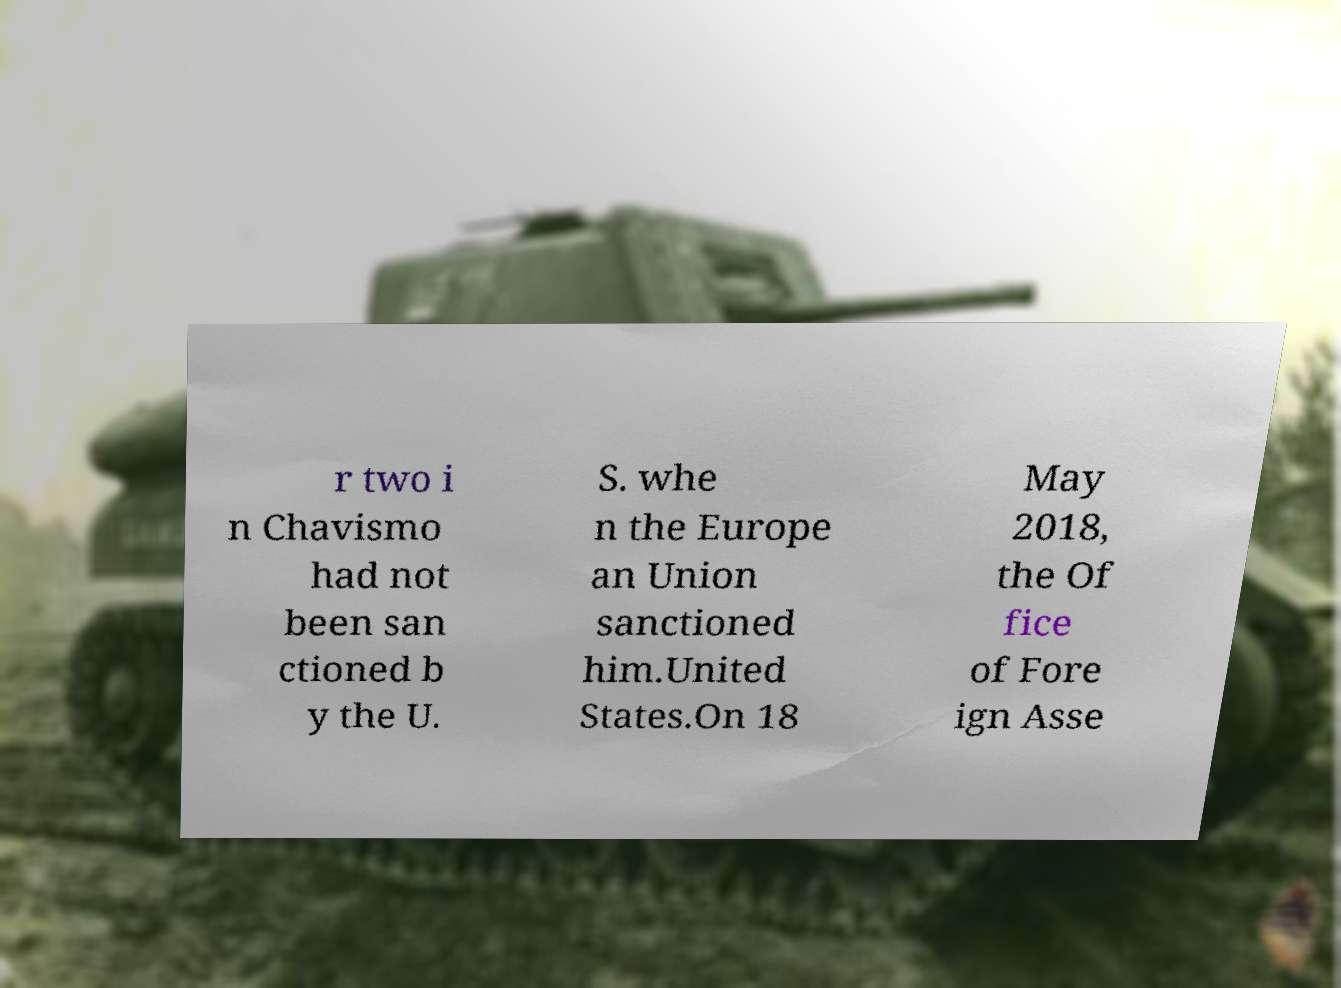What messages or text are displayed in this image? I need them in a readable, typed format. r two i n Chavismo had not been san ctioned b y the U. S. whe n the Europe an Union sanctioned him.United States.On 18 May 2018, the Of fice of Fore ign Asse 